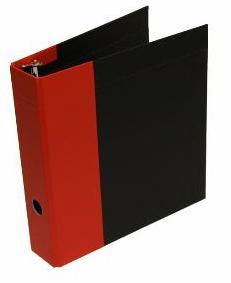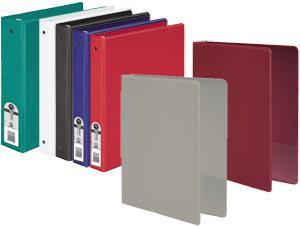The first image is the image on the left, the second image is the image on the right. Assess this claim about the two images: "Here, we see a total of nine binders.". Correct or not? Answer yes or no. No. The first image is the image on the left, the second image is the image on the right. Assess this claim about the two images: "There are exactly nine binders in the pair of images.". Correct or not? Answer yes or no. No. 